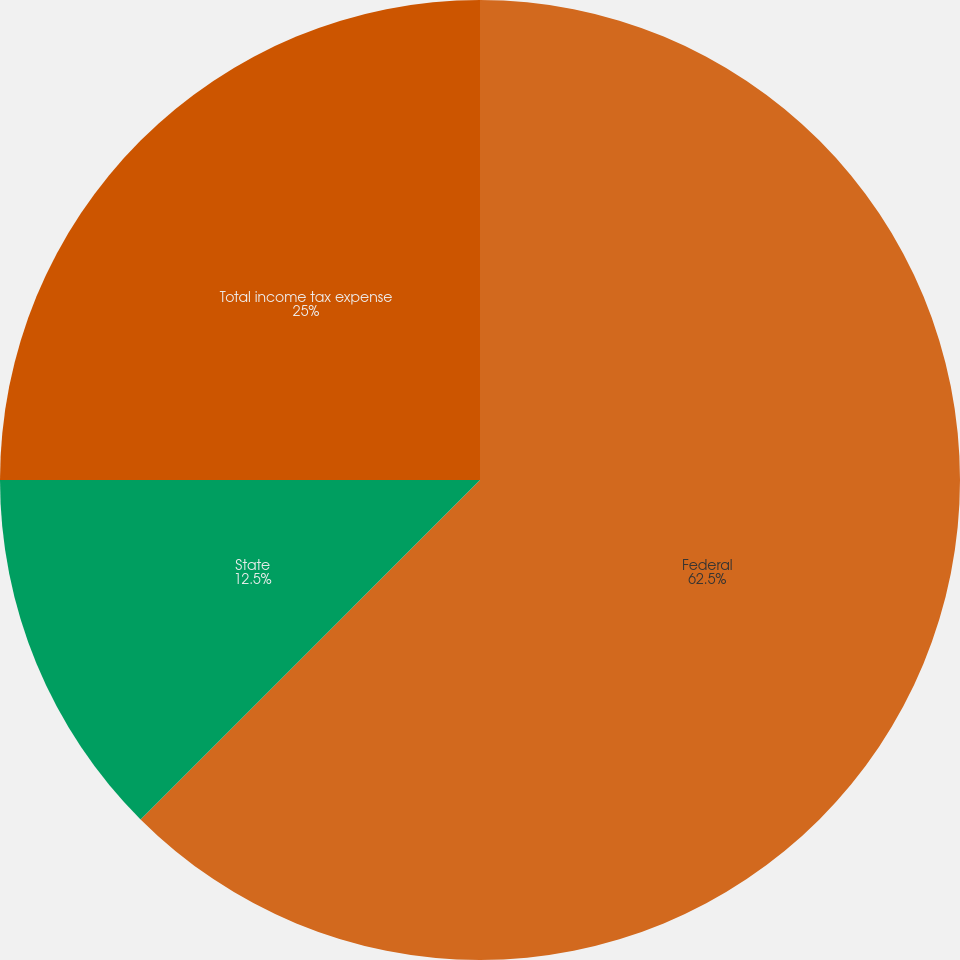<chart> <loc_0><loc_0><loc_500><loc_500><pie_chart><fcel>Federal<fcel>State<fcel>Total income tax expense<nl><fcel>62.5%<fcel>12.5%<fcel>25.0%<nl></chart> 